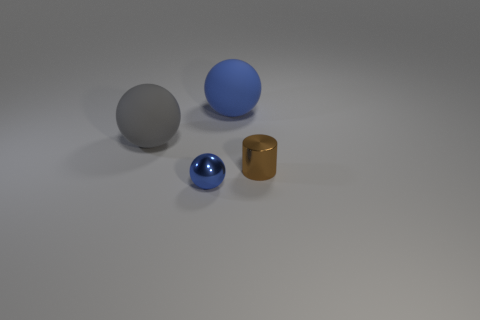Add 1 small purple balls. How many objects exist? 5 Subtract all cylinders. How many objects are left? 3 Subtract all gray matte balls. Subtract all cyan blocks. How many objects are left? 3 Add 4 large gray spheres. How many large gray spheres are left? 5 Add 3 brown metallic blocks. How many brown metallic blocks exist? 3 Subtract 0 yellow balls. How many objects are left? 4 